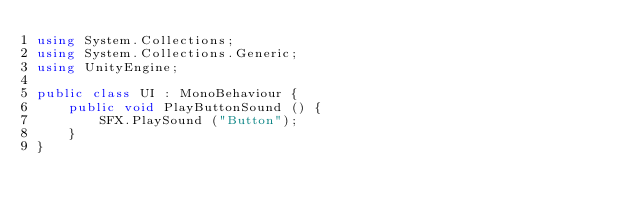<code> <loc_0><loc_0><loc_500><loc_500><_C#_>using System.Collections;
using System.Collections.Generic;
using UnityEngine;

public class UI : MonoBehaviour {
    public void PlayButtonSound () {
        SFX.PlaySound ("Button");
    }
}</code> 